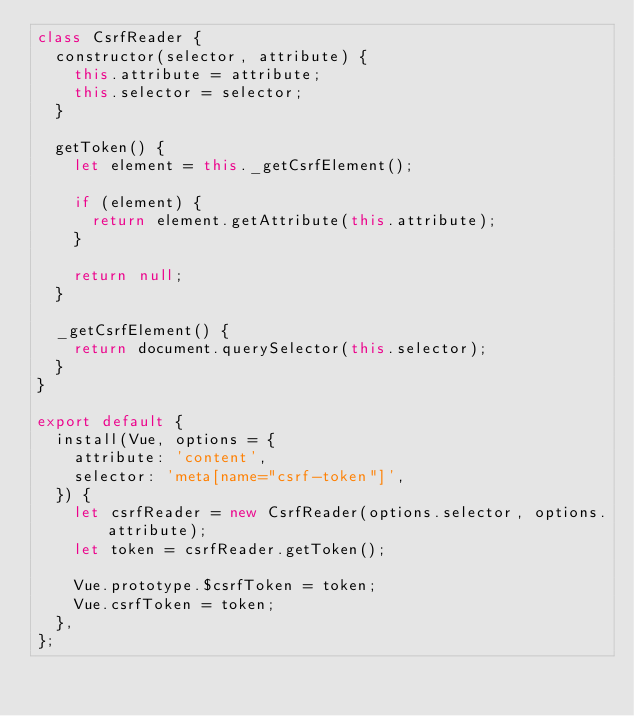<code> <loc_0><loc_0><loc_500><loc_500><_JavaScript_>class CsrfReader {
  constructor(selector, attribute) {
    this.attribute = attribute;
    this.selector = selector;
  }

  getToken() {
    let element = this._getCsrfElement();

    if (element) {
      return element.getAttribute(this.attribute);
    }

    return null;
  }

  _getCsrfElement() {
    return document.querySelector(this.selector);
  }
}

export default {
  install(Vue, options = {
    attribute: 'content',
    selector: 'meta[name="csrf-token"]',
  }) {
    let csrfReader = new CsrfReader(options.selector, options.attribute);
    let token = csrfReader.getToken();

    Vue.prototype.$csrfToken = token;
    Vue.csrfToken = token;
  },
};
</code> 